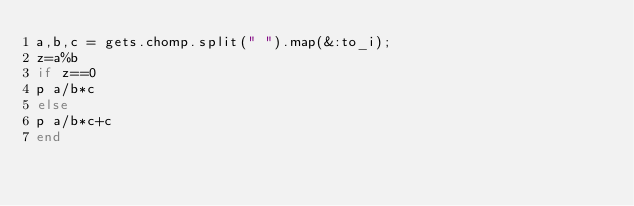Convert code to text. <code><loc_0><loc_0><loc_500><loc_500><_Ruby_>a,b,c = gets.chomp.split(" ").map(&:to_i);
z=a%b
if z==0
p a/b*c
else
p a/b*c+c
end
</code> 